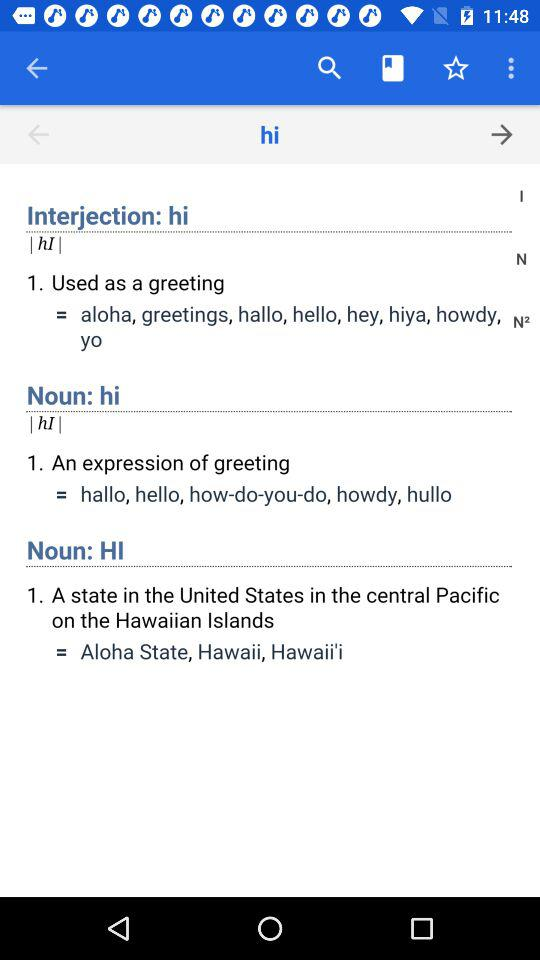How is "hi" used as an interjection? The "hi" is used as a greeting. 